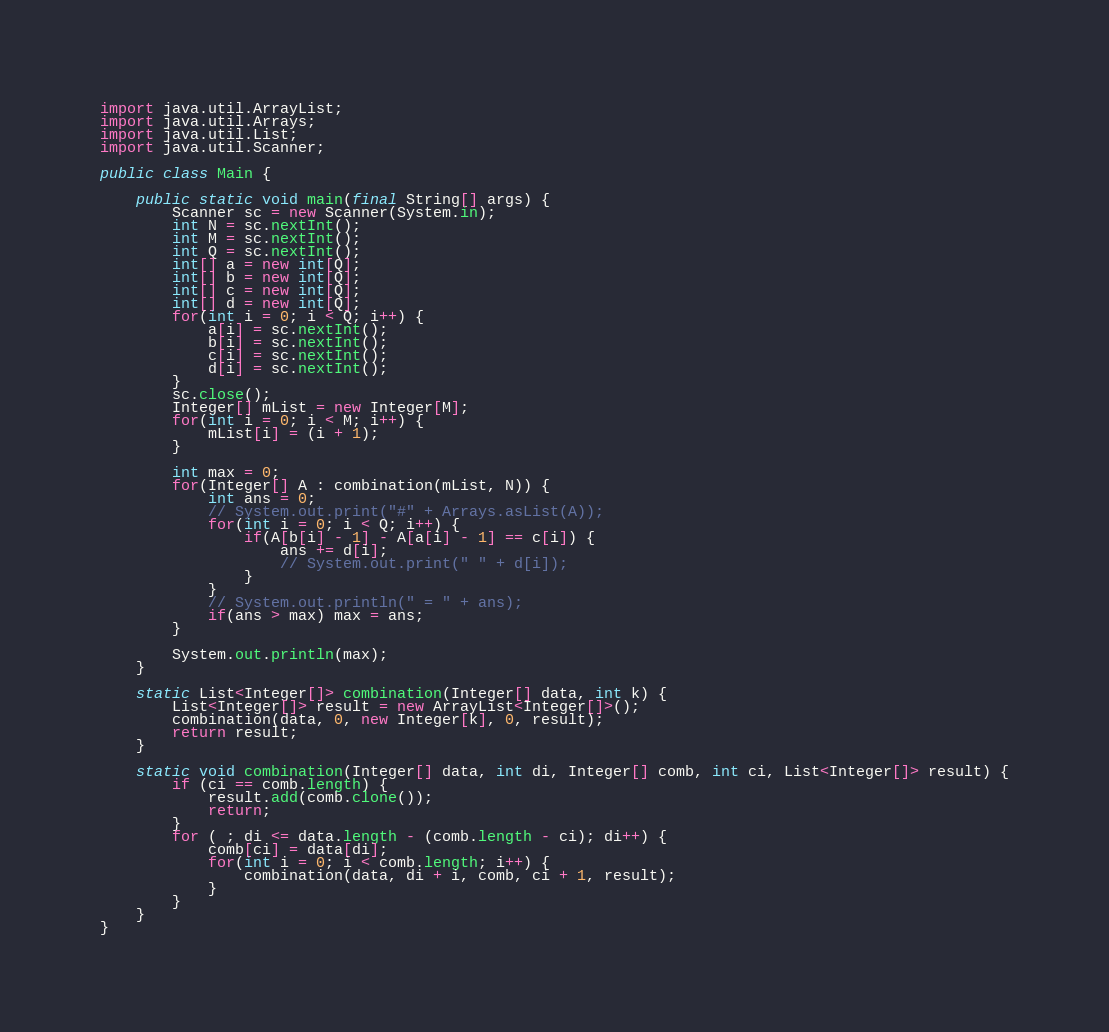Convert code to text. <code><loc_0><loc_0><loc_500><loc_500><_Java_>import java.util.ArrayList;
import java.util.Arrays;
import java.util.List;
import java.util.Scanner;

public class Main {

	public static void main(final String[] args) {
		Scanner sc = new Scanner(System.in);
		int N = sc.nextInt();
		int M = sc.nextInt();
		int Q = sc.nextInt();
		int[] a = new int[Q];
		int[] b = new int[Q];
		int[] c = new int[Q];
		int[] d = new int[Q];
		for(int i = 0; i < Q; i++) {
			a[i] = sc.nextInt();
			b[i] = sc.nextInt();
			c[i] = sc.nextInt();
			d[i] = sc.nextInt();
		}
		sc.close();
		Integer[] mList = new Integer[M];
		for(int i = 0; i < M; i++) {
			mList[i] = (i + 1);
		}
		
		int max = 0;
		for(Integer[] A : combination(mList, N)) {
			int ans = 0;
			// System.out.print("#" + Arrays.asList(A));
			for(int i = 0; i < Q; i++) {
				if(A[b[i] - 1] - A[a[i] - 1] == c[i]) {
					ans += d[i];
					// System.out.print(" " + d[i]);
				}
			}
			// System.out.println(" = " + ans);
			if(ans > max) max = ans;
		}
		
		System.out.println(max);
	}

    static List<Integer[]> combination(Integer[] data, int k) {
        List<Integer[]> result = new ArrayList<Integer[]>();
        combination(data, 0, new Integer[k], 0, result);
        return result;
    }

    static void combination(Integer[] data, int di, Integer[] comb, int ci, List<Integer[]> result) {
        if (ci == comb.length) {
            result.add(comb.clone());
            return;
        }
        for ( ; di <= data.length - (comb.length - ci); di++) {
			comb[ci] = data[di];
			for(int i = 0; i < comb.length; i++) {
				combination(data, di + i, comb, ci + 1, result);
			}
        }
    }
}</code> 